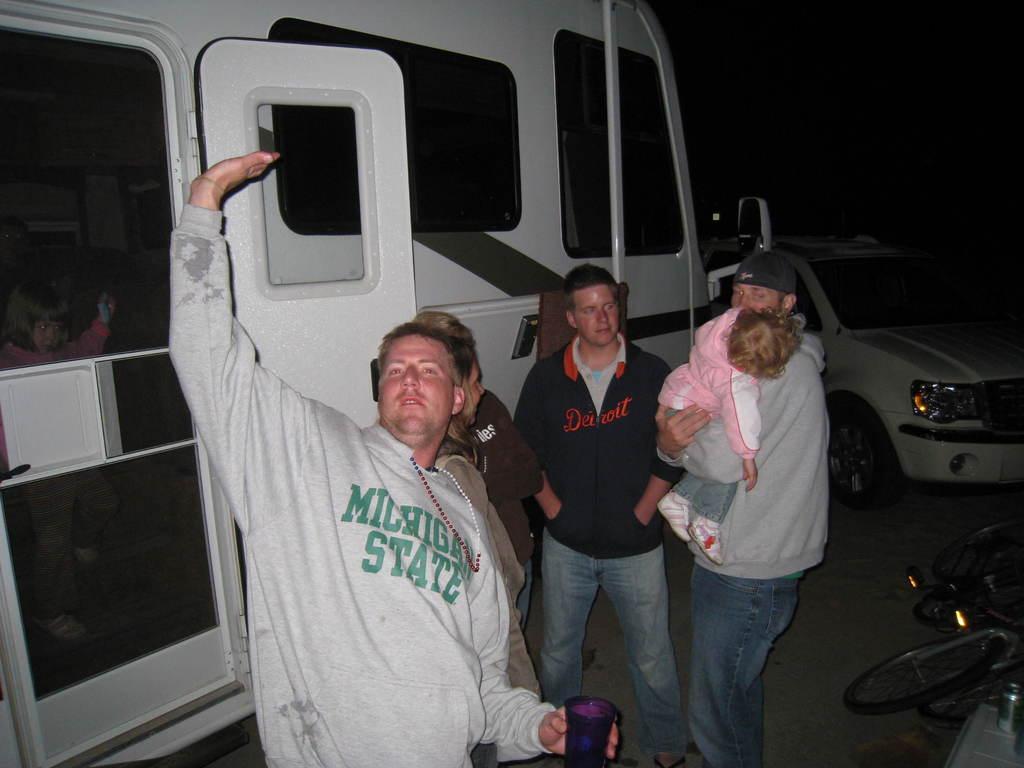Could you give a brief overview of what you see in this image? In the foreground of the picture I can see four persons standing on the road. I can see a man on the left side holding a glass in his left hand. There is a man on the right side is holding a baby. I can see a bus on the left side. There is a car on the right side. I can see a bicycle on the bottom right side of the picture. 